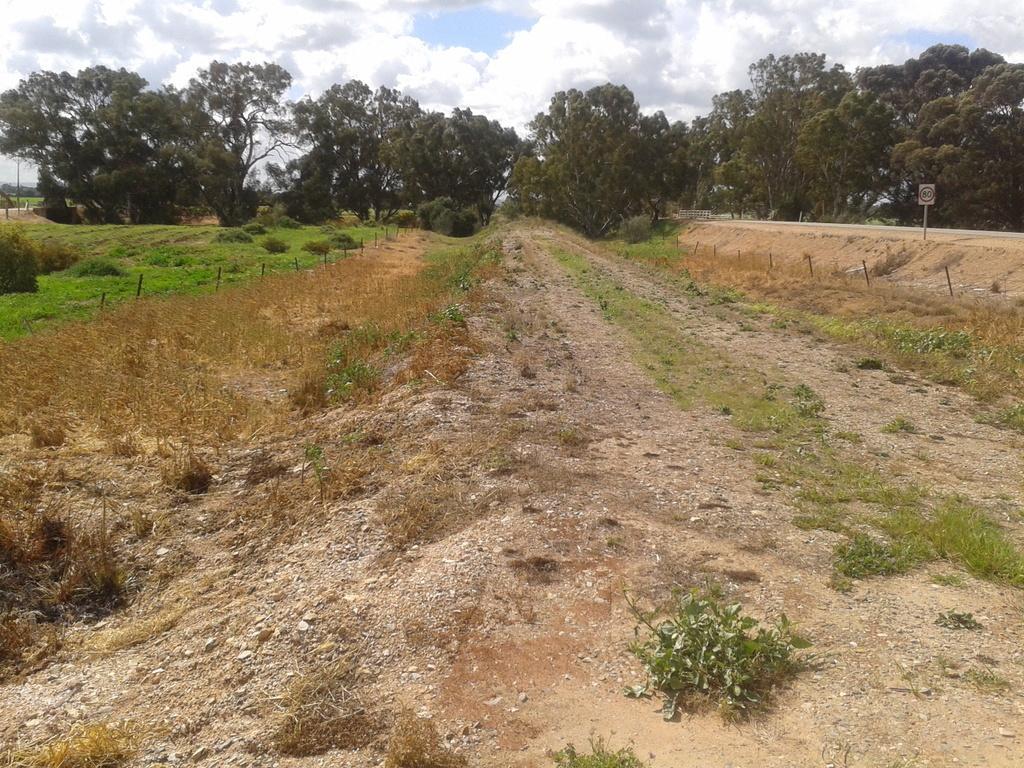In one or two sentences, can you explain what this image depicts? In this picture we can see farmland. On the right there is a road, sign board and fencing. In the background we can see many trees. On the top we can see sky and clouds. On the left we can see grass. 